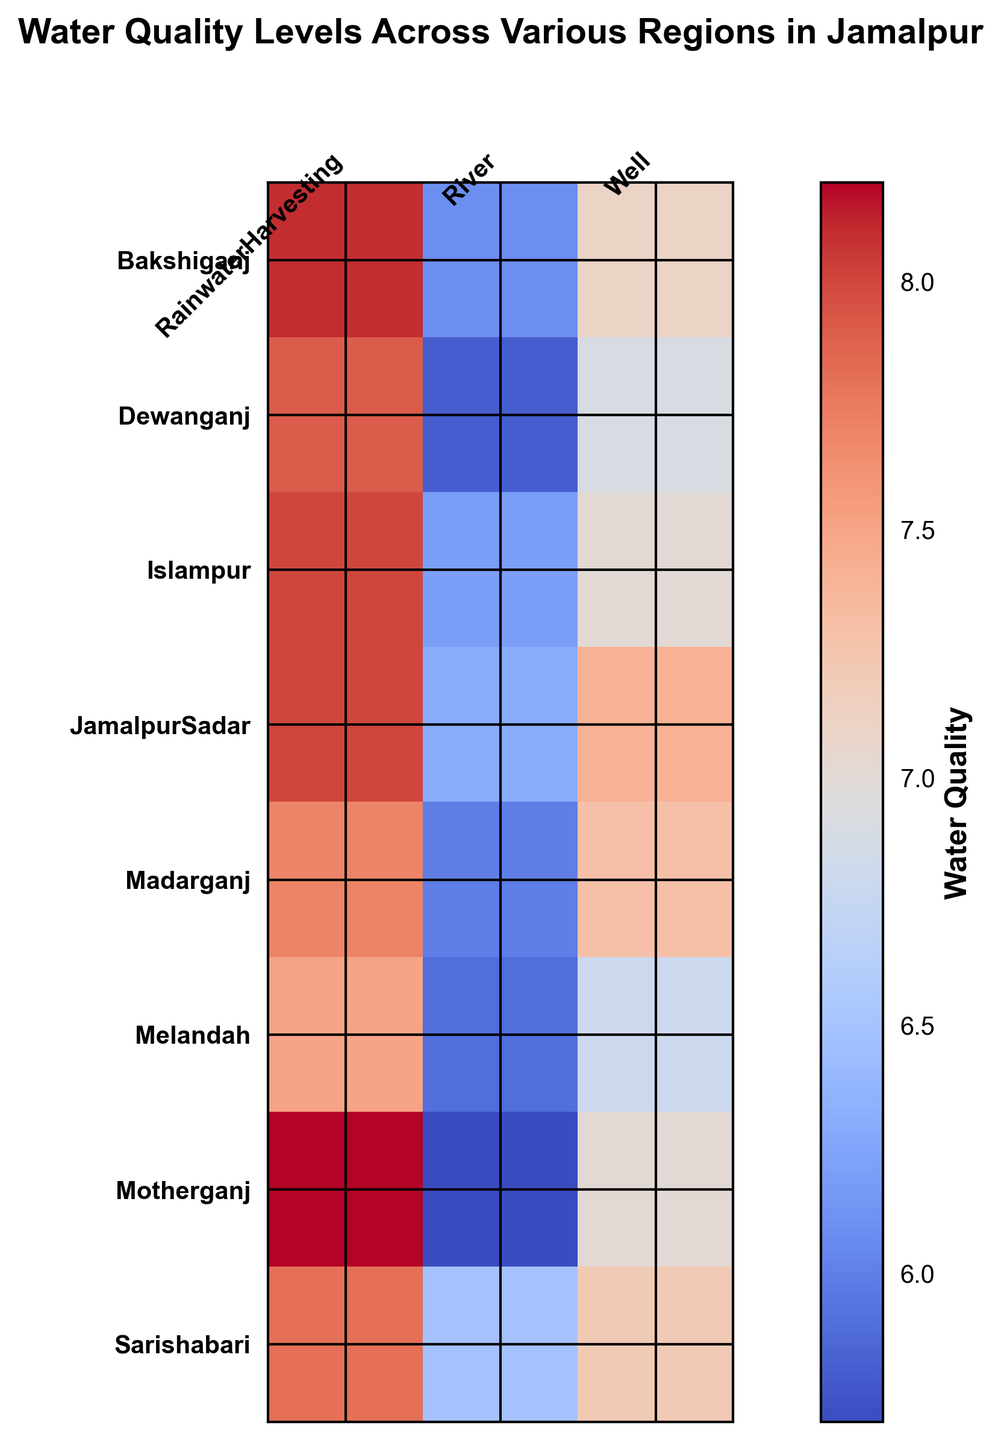Which region has the highest water quality level from rainwater harvesting? Rainwater harvesting quality levels can be visually identified from the heatmap. The highest value in the rainwater harvesting column is 8.2, which corresponds to Motherganj.
Answer: Motherganj What is the average water quality level for river sources across all regions? To calculate the average, add all the river water quality levels and divide by the number of regions. The values are 6.5 (Sarishabari), 5.9 (Melandah), 6.2 (Islampur), 5.8 (Dewanganj), 6.1 (Bakshiganj), 5.7 (Motherganj), 6.0 (Madarganj), and 6.3 (JamalpurSadar). The sum is 48.5, and there are 8 regions, so the average is 48.5/8 = 6.06.
Answer: 6.06 Which region has the lowest water quality level from wells? Well water quality levels can be identified from the heatmap. The lowest value in the well column is 6.8, which corresponds to Melandah.
Answer: Melandah Between Sarishabari and Dewanganj, which region has better average water quality across all sources? Calculate the average water quality for each source in the two regions. Sarishabari: (7.2 + 6.5 + 7.8)/3 = 7.17. Dewanganj: (6.9 + 5.8 + 7.9)/3 = 6.87. Sarishabari has a better average water quality.
Answer: Sarishabari Compare the rainwater harvesting quality levels of Bakshiganj and Madarganj. Which one is higher? Identify the rainwater harvesting quality levels for Bakshiganj (8.1) and Madarganj (7.7). Comparing 8.1 and 7.7, Bakshiganj has the higher value.
Answer: Bakshiganj 